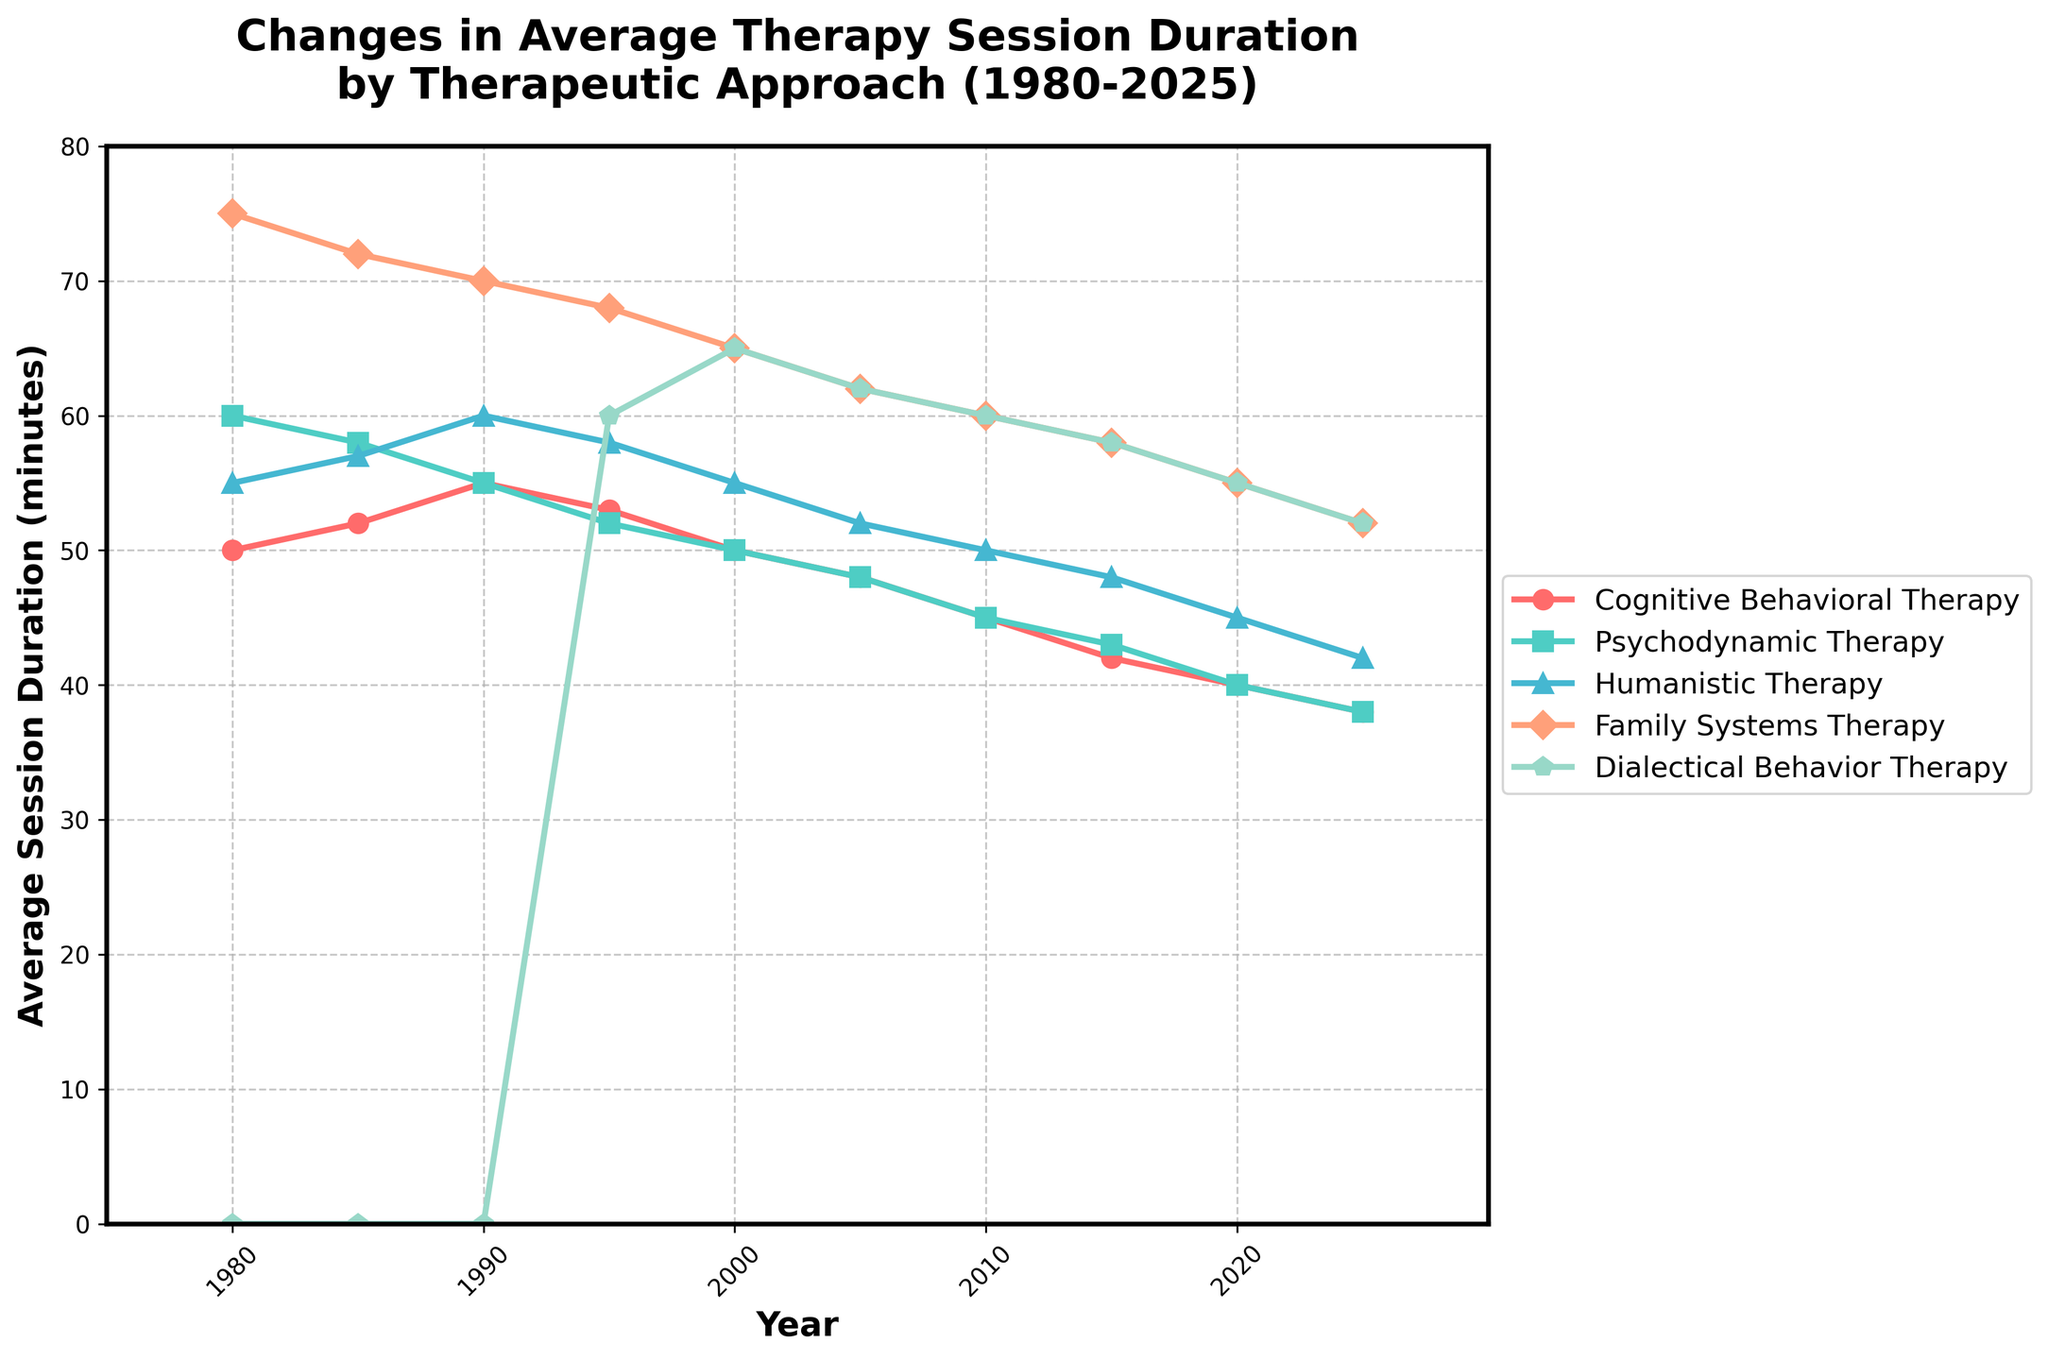What is the average session duration for Cognitive Behavioral Therapy (CBT) in the year 2000? To find the average session duration for CBT in 2000, locate the point for CBT on the line chart corresponding to the year 2000. The value is 50 minutes.
Answer: 50 minutes Which therapeutic approach shows the greatest decline in average session duration from 1980 to 2025? Compare the starting and ending points of each therapy's trend line in the chart. Calculate the difference between the average session durations in 1980 and 2025 for each approach. 
- CBT: 50 - 38 = 12
- Psychodynamic Therapy: 60 - 38 = 22
- Humanistic Therapy: 55 - 42 = 13
- Family Systems Therapy: 75 - 52 = 23
- DBT: Not applicable until 1995.
Family Systems Therapy has the greatest decline (23 minutes).
Answer: Family Systems Therapy By how many minutes did the average session duration for Dialectical Behavior Therapy (DBT) decrease from 1995 to 2025? Locate the values for DBT for 1995 and 2025, which are 60 and 52 minutes respectively. The difference is 60 - 52 = 8 minutes.
Answer: 8 minutes Which year shows an equal average session duration for Cognitive Behavioral Therapy (CBT) and Humanistic Therapy? Look for the intersection points of the lines representing CBT and Humanistic Therapy. Both have equal values (50 minutes) in the year 2000.
Answer: 2000 How does the average session duration for Family Systems Therapy in 2010 compare to that in 1985? Locate the points for Family Systems Therapy in 2010 and 1985. The duration for 1985 is 72 minutes, and for 2010 it's 60 minutes. The 2010 duration is 12 minutes shorter than in 1985.
Answer: 12 minutes shorter What is the rate of decline in average session duration per decade for Humanistic Therapy from 1980 to 2020? Find the starting (55) and ending (45) values for 1980 and 2020, respectively, for Humanistic Therapy. The total decline over 40 years is 55 - 45 = 10 minutes. The rate per decade (10 years) is 10/4 = 2.5 minutes per decade.
Answer: 2.5 minutes per decade Which therapeutic approach had the smallest change in average session duration from 1980 to 1985? Compare the changes for 1980 and 1985 for each approach:
- CBT: 52 - 50 = 2
- Psychodynamic: 58 - 60 = 2
- Humanistic: 57 - 55 = 2
- Family Systems: 72 - 75 = -3
- DBT: Not applicable.
Since CBT, Psychodynamic, and Humanistic approaches all show a 2-minute change, they are tied for the smallest change.
Answer: CBT, Psychodynamic Therapy, Humanistic Therapy What is the sum of the average session durations for Cognitive Behavioral Therapy and Dialectical Behavior Therapy in 2015? Find the values for CBT (42) and DBT (58) in 2015 and add them: 42 + 58 = 100 minutes.
Answer: 100 minutes Which therapy's line color is blue? Refer to the color of the lines in the chart. The line representing Dialectical Behavior Therapy (DBT) is blue.
Answer: Dialectical Behavior Therapy (DBT) 